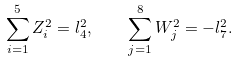<formula> <loc_0><loc_0><loc_500><loc_500>\sum ^ { 5 } _ { i = 1 } Z ^ { 2 } _ { i } = l ^ { 2 } _ { 4 } , \quad \sum ^ { 8 } _ { j = 1 } W ^ { 2 } _ { j } = - l ^ { 2 } _ { 7 } .</formula> 